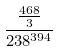Convert formula to latex. <formula><loc_0><loc_0><loc_500><loc_500>\frac { \frac { 4 6 8 } { 3 } } { 2 3 8 ^ { 3 9 4 } }</formula> 